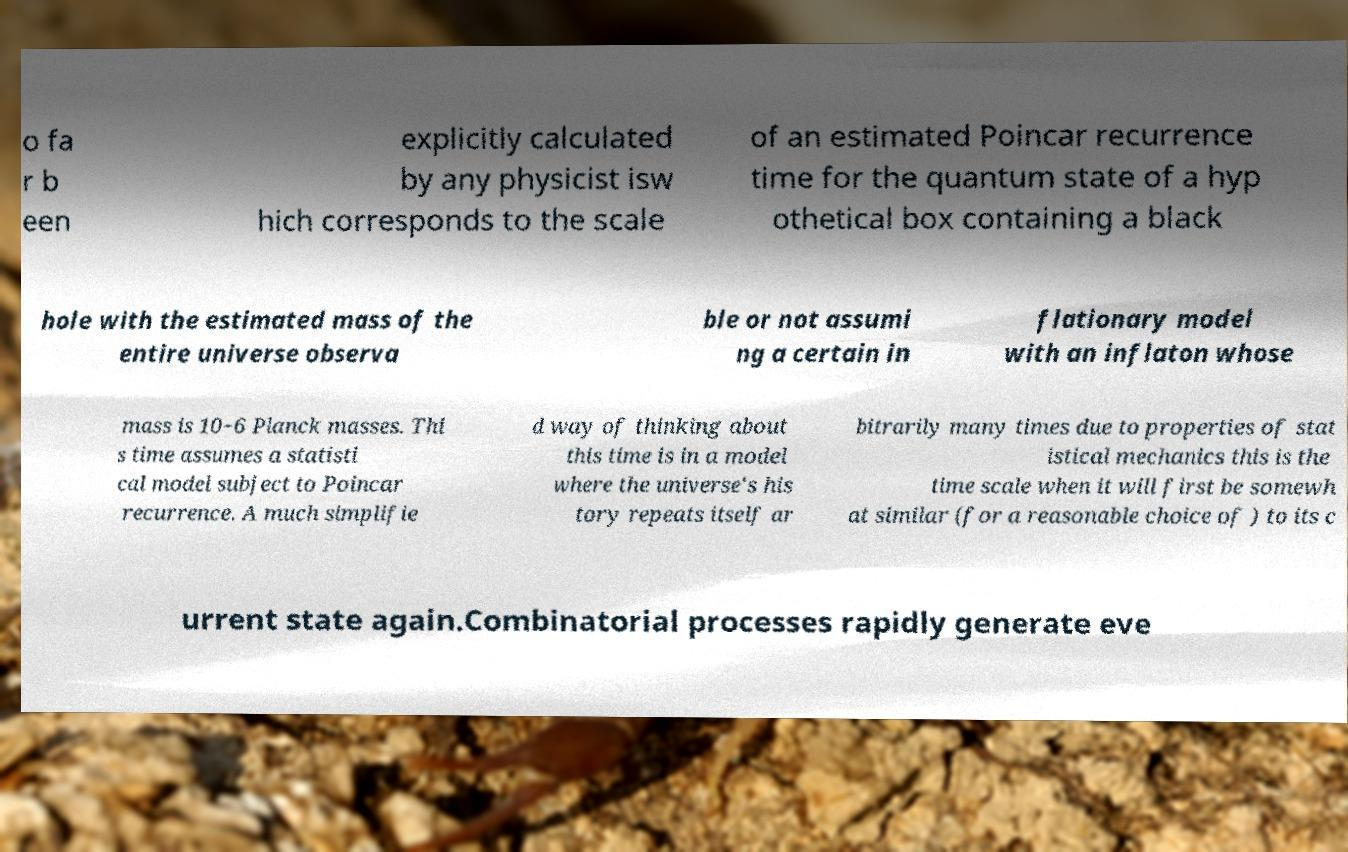There's text embedded in this image that I need extracted. Can you transcribe it verbatim? o fa r b een explicitly calculated by any physicist isw hich corresponds to the scale of an estimated Poincar recurrence time for the quantum state of a hyp othetical box containing a black hole with the estimated mass of the entire universe observa ble or not assumi ng a certain in flationary model with an inflaton whose mass is 10−6 Planck masses. Thi s time assumes a statisti cal model subject to Poincar recurrence. A much simplifie d way of thinking about this time is in a model where the universe's his tory repeats itself ar bitrarily many times due to properties of stat istical mechanics this is the time scale when it will first be somewh at similar (for a reasonable choice of ) to its c urrent state again.Combinatorial processes rapidly generate eve 